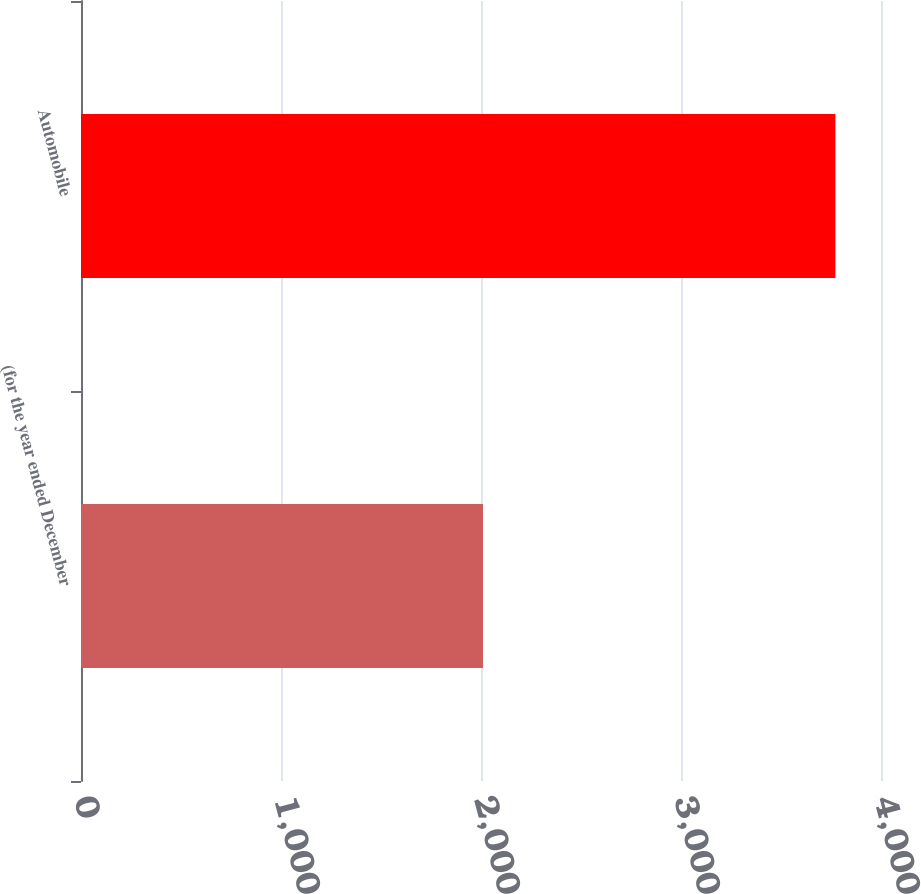<chart> <loc_0><loc_0><loc_500><loc_500><bar_chart><fcel>(for the year ended December<fcel>Automobile<nl><fcel>2010<fcel>3772<nl></chart> 